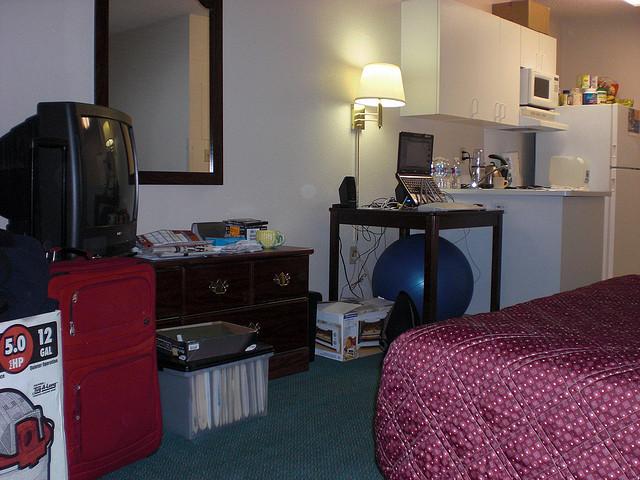Is there a mirror in the room?
Quick response, please. Yes. What is the television set sitting on?
Quick response, please. Suitcase. What color is the ball?
Short answer required. Blue. 